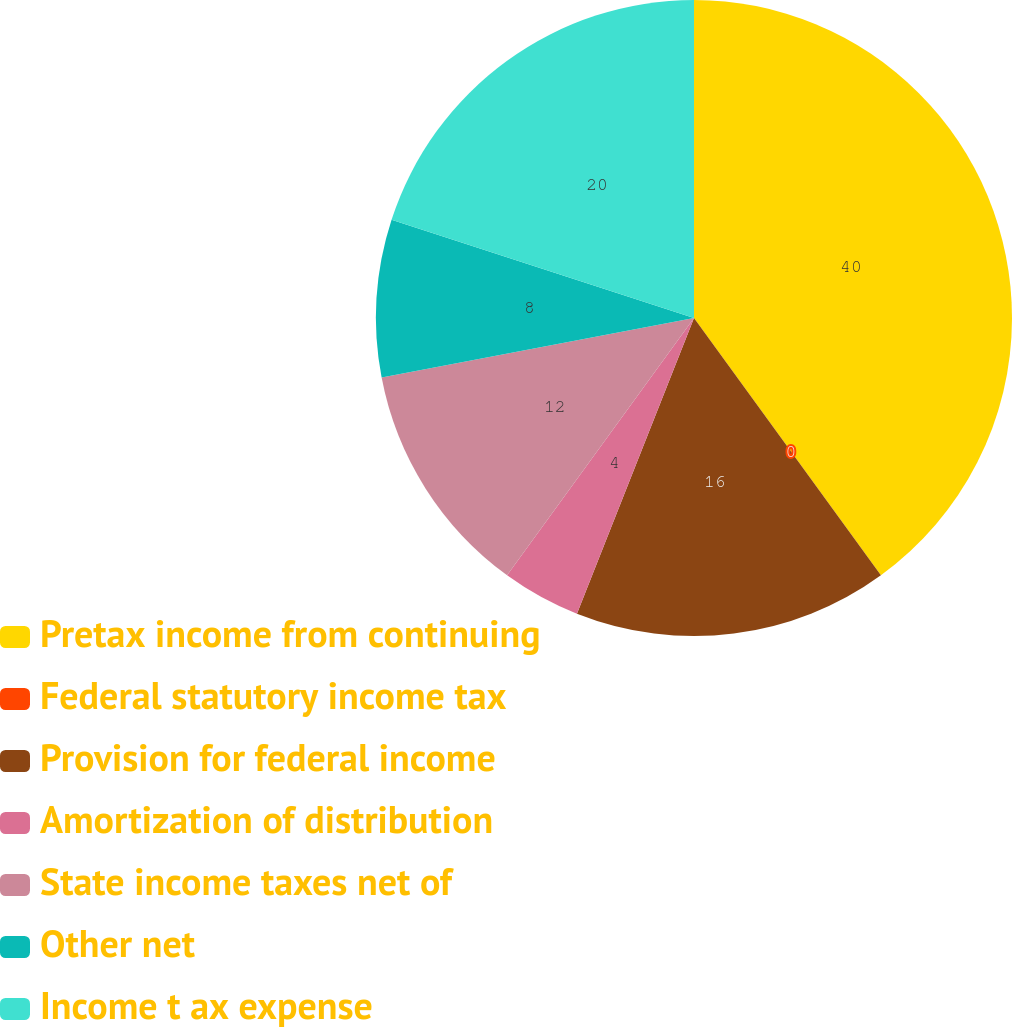Convert chart. <chart><loc_0><loc_0><loc_500><loc_500><pie_chart><fcel>Pretax income from continuing<fcel>Federal statutory income tax<fcel>Provision for federal income<fcel>Amortization of distribution<fcel>State income taxes net of<fcel>Other net<fcel>Income t ax expense<nl><fcel>40.0%<fcel>0.0%<fcel>16.0%<fcel>4.0%<fcel>12.0%<fcel>8.0%<fcel>20.0%<nl></chart> 